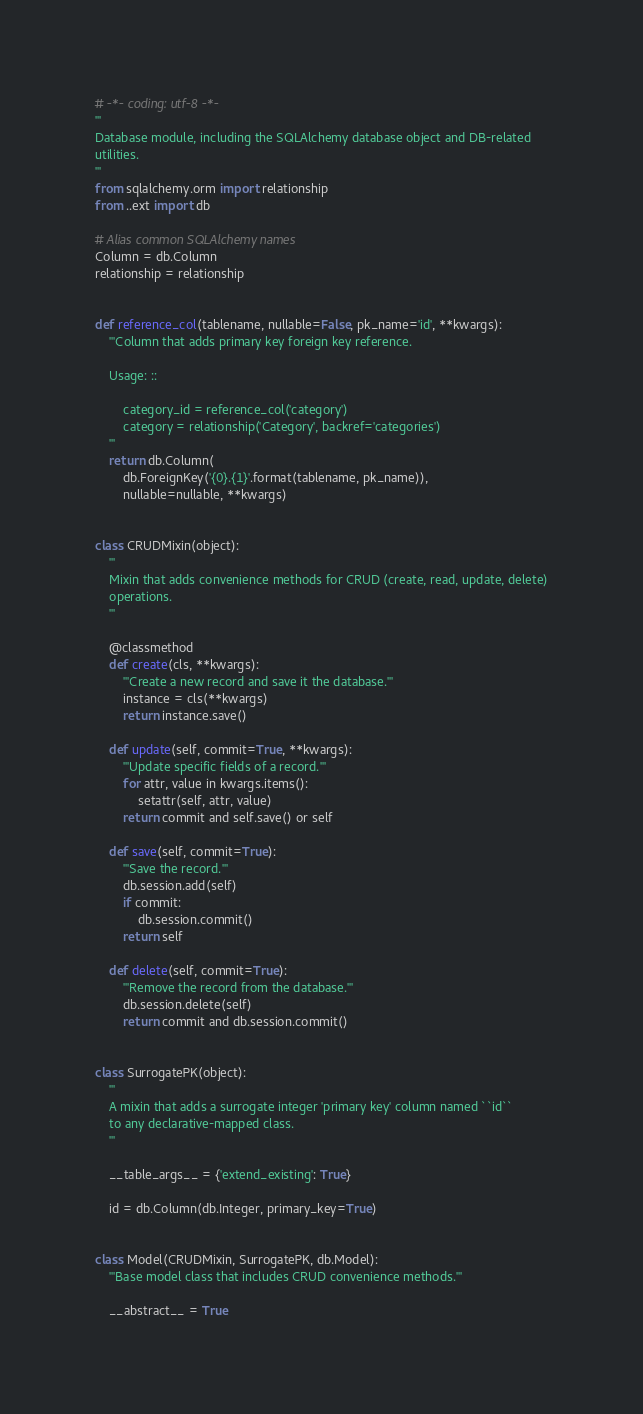<code> <loc_0><loc_0><loc_500><loc_500><_Python_># -*- coding: utf-8 -*-
'''
Database module, including the SQLAlchemy database object and DB-related
utilities.
'''
from sqlalchemy.orm import relationship
from ..ext import db

# Alias common SQLAlchemy names
Column = db.Column
relationship = relationship


def reference_col(tablename, nullable=False, pk_name='id', **kwargs):
    '''Column that adds primary key foreign key reference.

    Usage: ::

        category_id = reference_col('category')
        category = relationship('Category', backref='categories')
    '''
    return db.Column(
        db.ForeignKey('{0}.{1}'.format(tablename, pk_name)),
        nullable=nullable, **kwargs)


class CRUDMixin(object):
    '''
    Mixin that adds convenience methods for CRUD (create, read, update, delete)
    operations.
    '''

    @classmethod
    def create(cls, **kwargs):
        '''Create a new record and save it the database.'''
        instance = cls(**kwargs)
        return instance.save()

    def update(self, commit=True, **kwargs):
        '''Update specific fields of a record.'''
        for attr, value in kwargs.items():
            setattr(self, attr, value)
        return commit and self.save() or self

    def save(self, commit=True):
        '''Save the record.'''
        db.session.add(self)
        if commit:
            db.session.commit()
        return self

    def delete(self, commit=True):
        '''Remove the record from the database.'''
        db.session.delete(self)
        return commit and db.session.commit()


class SurrogatePK(object):
    '''
    A mixin that adds a surrogate integer 'primary key' column named ``id``
    to any declarative-mapped class.
    '''

    __table_args__ = {'extend_existing': True}

    id = db.Column(db.Integer, primary_key=True)


class Model(CRUDMixin, SurrogatePK, db.Model):
    '''Base model class that includes CRUD convenience methods.'''

    __abstract__ = True
</code> 